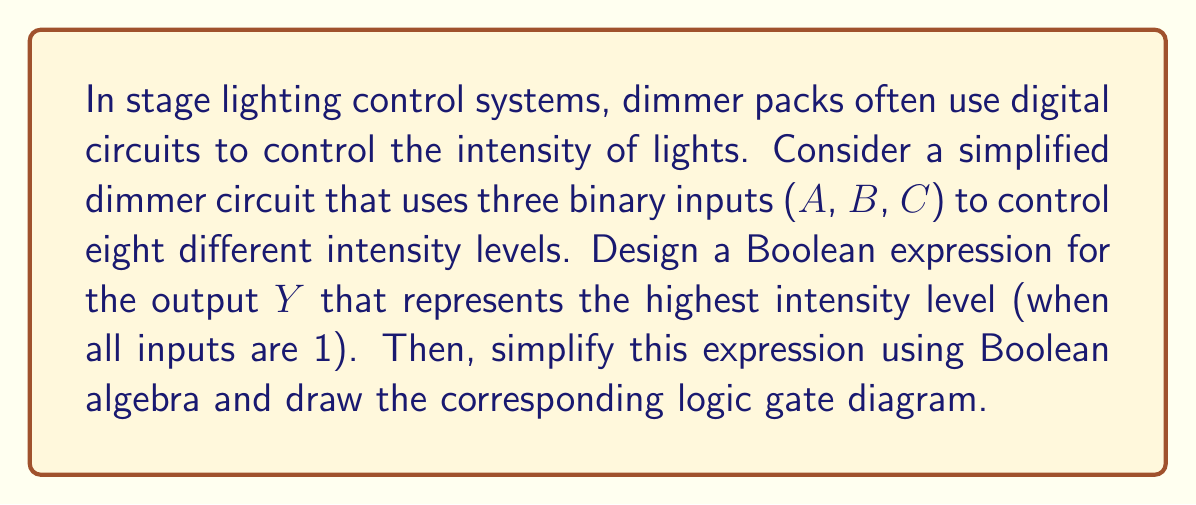What is the answer to this math problem? To solve this problem, we'll follow these steps:

1. Determine the Boolean expression for the highest intensity level:
   The highest intensity level occurs when all inputs are 1, so the initial Boolean expression is:
   $$Y = A \cdot B \cdot C$$

2. Simplify the expression:
   This expression is already in its simplest form, as it represents the AND operation of all inputs.

3. Draw the logic gate diagram:
   We can represent this using a single AND gate with three inputs.

   [asy]
   import geometry;

   // Define points for the AND gate
   pair A = (0,40);
   pair B = (0,20);
   pair C = (0,0);
   pair D = (60,20);

   // Draw AND gate
   draw(A--B--C);
   draw(arc((30,20),30,270,90));

   // Draw input and output lines
   draw((-20,40)--(0,40));
   draw((-20,20)--(0,20));
   draw((-20,0)--(0,0));
   draw((60,20)--(80,20));

   // Label inputs and output
   label("A", (-25,40), E);
   label("B", (-25,20), E);
   label("C", (-25,0), E);
   label("Y", (85,20), W);
   [/asy]

This diagram represents the Boolean expression $Y = A \cdot B \cdot C$, which activates the highest intensity level only when all inputs are 1.

In the context of stage lighting, this circuit ensures that the maximum brightness is achieved only when all control switches are activated, providing a safeguard against accidental full-intensity illumination.
Answer: The simplified Boolean expression for the highest intensity level is $Y = A \cdot B \cdot C$, represented by a single AND gate with three inputs in the logic gate diagram. 